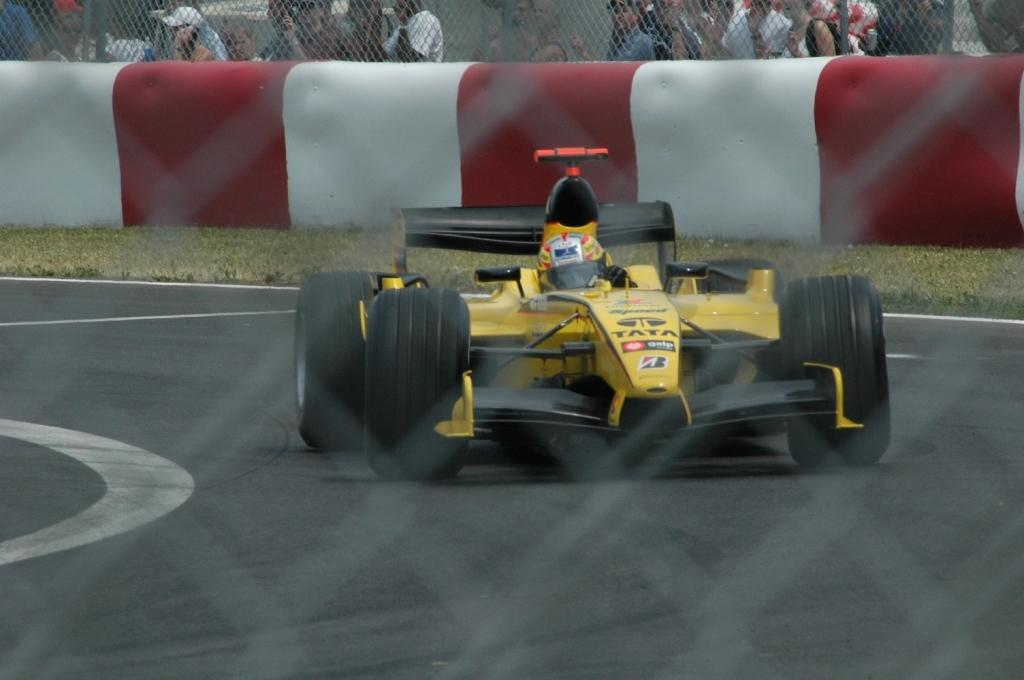What is on the road in the image? There is a vehicle on the road in the image. What can be seen behind the vehicle? There is grassland behind the vehicle. What is happening with the persons in the image? There are persons behind a fence in the image. Who is inside the vehicle? A person is sitting in the vehicle. What safety gear is the person in the vehicle wearing? The person in the vehicle is wearing a helmet. Where is the library located in the image? There is no library present in the image. What type of animal is grazing in the grassland behind the vehicle? There is no animal visible in the grassland behind the vehicle. 